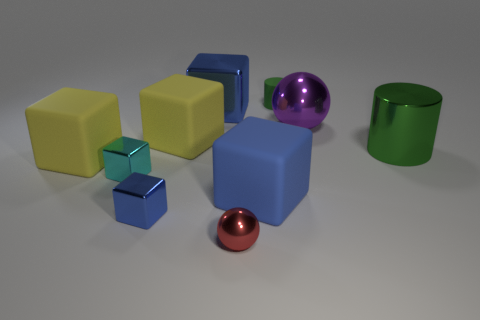How many objects have reflective surfaces? The objects in the image with reflective surfaces include the two balls and the cylindrical canister, making a total of three reflective objects. 